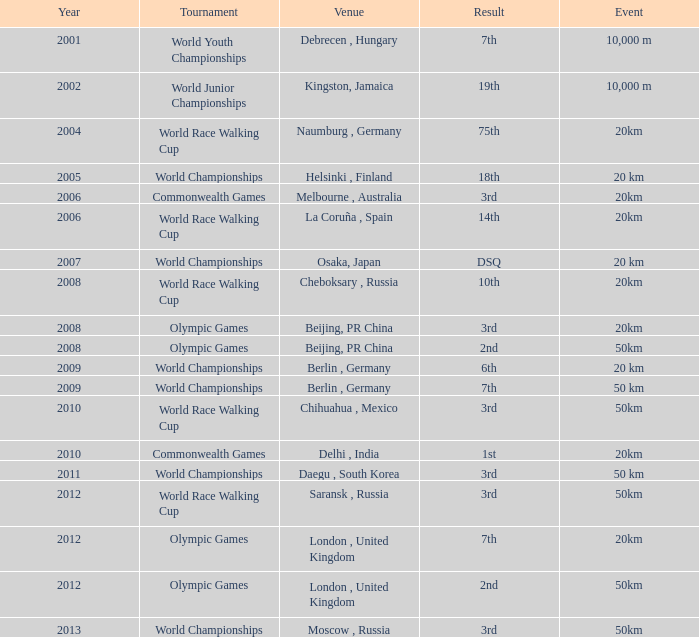What is the year of the tournament played at Melbourne, Australia? 2006.0. 